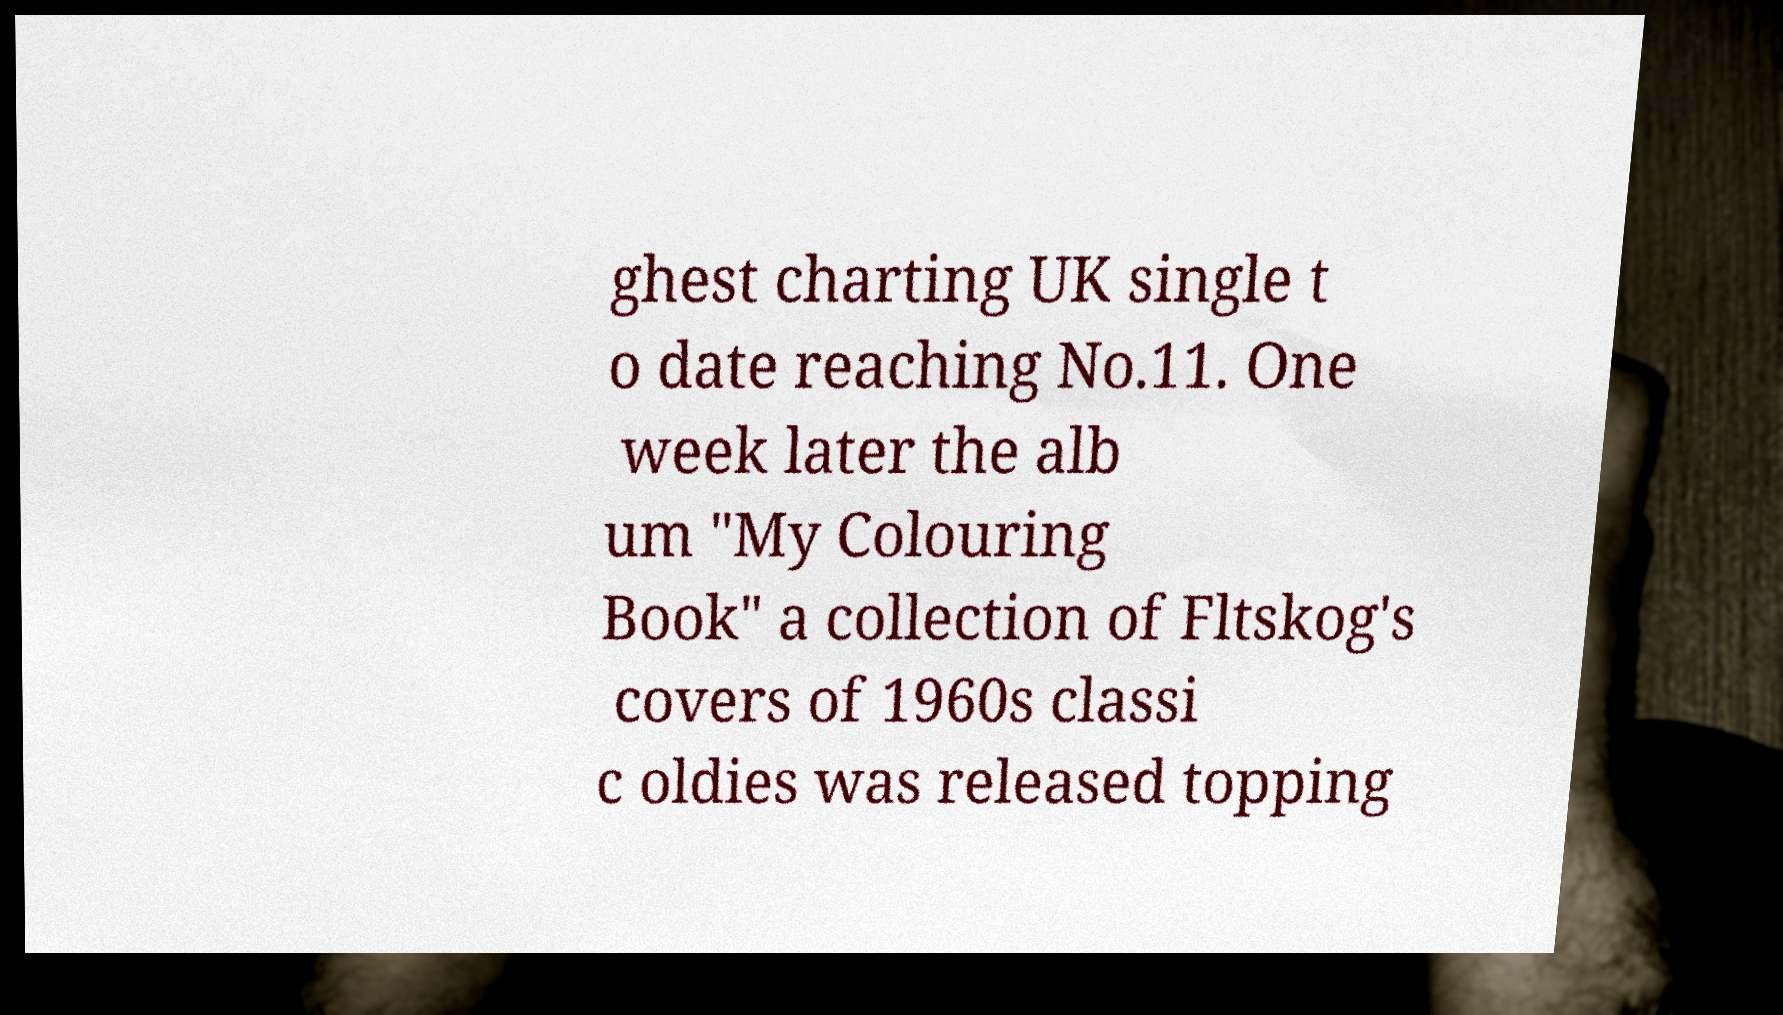Can you accurately transcribe the text from the provided image for me? ghest charting UK single t o date reaching No.11. One week later the alb um "My Colouring Book" a collection of Fltskog's covers of 1960s classi c oldies was released topping 